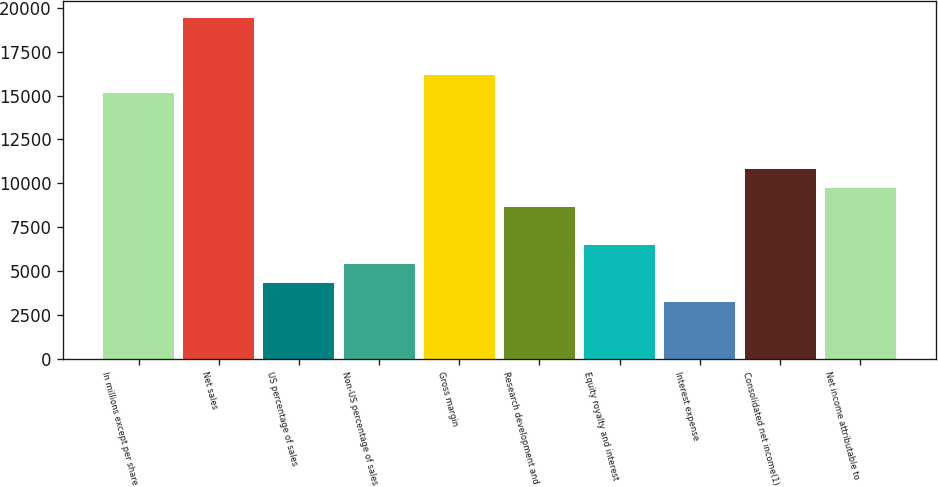Convert chart to OTSL. <chart><loc_0><loc_0><loc_500><loc_500><bar_chart><fcel>In millions except per share<fcel>Net sales<fcel>US percentage of sales<fcel>Non-US percentage of sales<fcel>Gross margin<fcel>Research development and<fcel>Equity royalty and interest<fcel>Interest expense<fcel>Consolidated net income(1)<fcel>Net income attributable to<nl><fcel>15119.7<fcel>19439.4<fcel>4320.42<fcel>5400.35<fcel>16199.6<fcel>8640.14<fcel>6480.28<fcel>3240.49<fcel>10800<fcel>9720.07<nl></chart> 